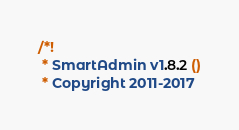<code> <loc_0><loc_0><loc_500><loc_500><_CSS_>/*!
 * SmartAdmin v1.8.2 ()
 * Copyright 2011-2017 </code> 